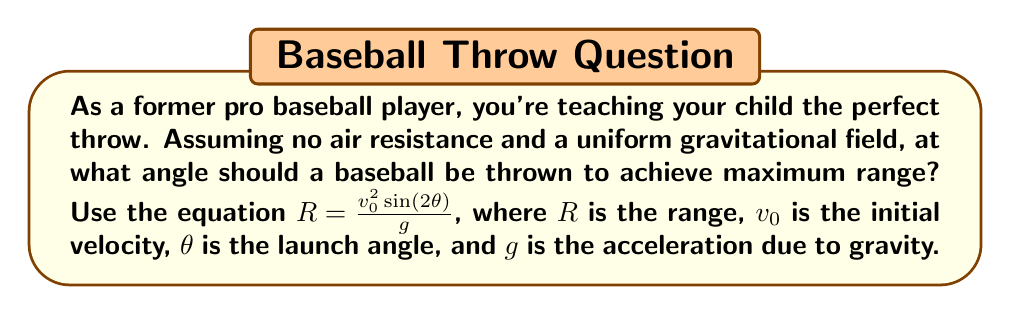Can you solve this math problem? To find the optimal angle for maximum range, we need to maximize the function:

$$R = \frac{v_0^2 \sin(2\theta)}{g}$$

1) The only variable in this equation is $\theta$, so we need to find the value of $\theta$ that maximizes $\sin(2\theta)$.

2) The sine function reaches its maximum value of 1 when its argument is 90° or $\frac{\pi}{2}$ radians.

3) So, we want:

   $$2\theta = \frac{\pi}{2}$$

4) Solving for $\theta$:

   $$\theta = \frac{\pi}{4} = 45°$$

5) We can verify this is a maximum by checking values slightly above and below 45°, or by using calculus to find the derivative and confirm it's zero at 45°.

Therefore, to achieve the maximum range, the baseball should be thrown at a 45° angle to the horizontal.
Answer: 45° 